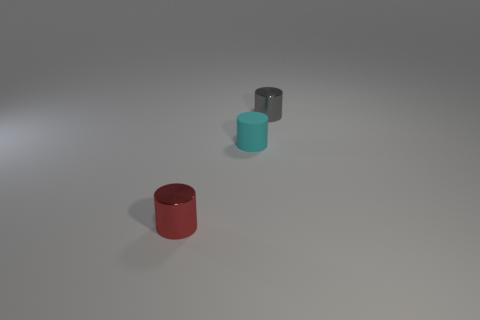There is a cylinder that is both to the right of the red cylinder and in front of the tiny gray metal cylinder; what size is it?
Make the answer very short. Small. What is the material of the other small gray thing that is the same shape as the matte object?
Give a very brief answer. Metal. There is a shiny thing in front of the gray object; does it have the same size as the small cyan object?
Ensure brevity in your answer.  Yes. There is a cylinder that is both on the left side of the gray cylinder and behind the tiny red shiny cylinder; what is its color?
Ensure brevity in your answer.  Cyan. There is a shiny object that is left of the matte cylinder; what number of gray cylinders are to the left of it?
Ensure brevity in your answer.  0. Is the rubber object the same shape as the small gray metallic object?
Your response must be concise. Yes. Are there any other things that have the same color as the tiny rubber cylinder?
Provide a short and direct response. No. There is a gray thing; is its shape the same as the shiny object that is in front of the small cyan object?
Keep it short and to the point. Yes. The metal cylinder on the left side of the small metal thing that is behind the shiny thing in front of the small matte cylinder is what color?
Offer a terse response. Red. Is there any other thing that is the same material as the small cyan thing?
Give a very brief answer. No. 